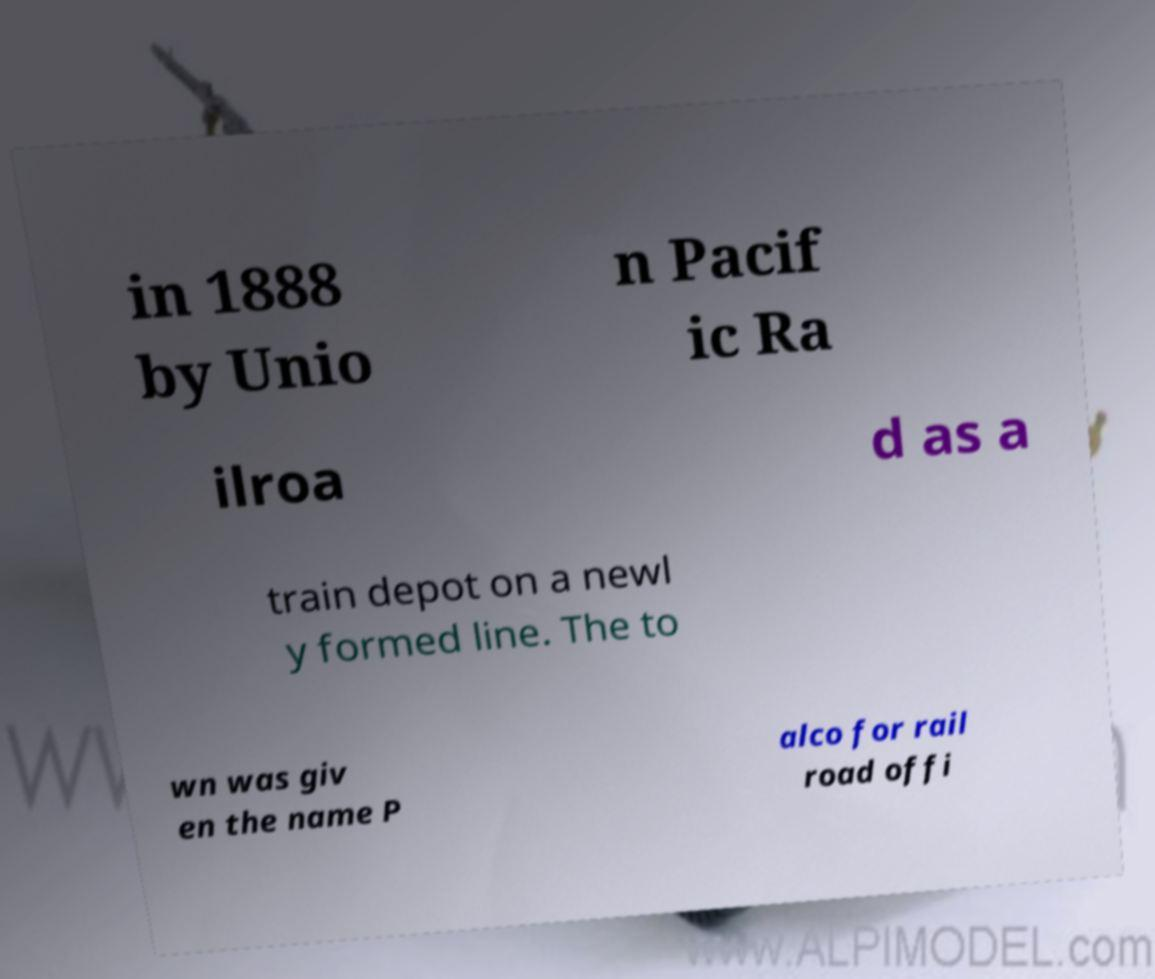There's text embedded in this image that I need extracted. Can you transcribe it verbatim? in 1888 by Unio n Pacif ic Ra ilroa d as a train depot on a newl y formed line. The to wn was giv en the name P alco for rail road offi 